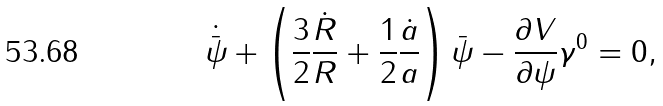Convert formula to latex. <formula><loc_0><loc_0><loc_500><loc_500>\dot { \bar { \psi } } + \left ( \frac { 3 } { 2 } \frac { \dot { R } } { R } + \frac { 1 } { 2 } \frac { \dot { a } } { a } \right ) \bar { \psi } - \frac { \partial V } { \partial \psi } \gamma ^ { 0 } = 0 ,</formula> 